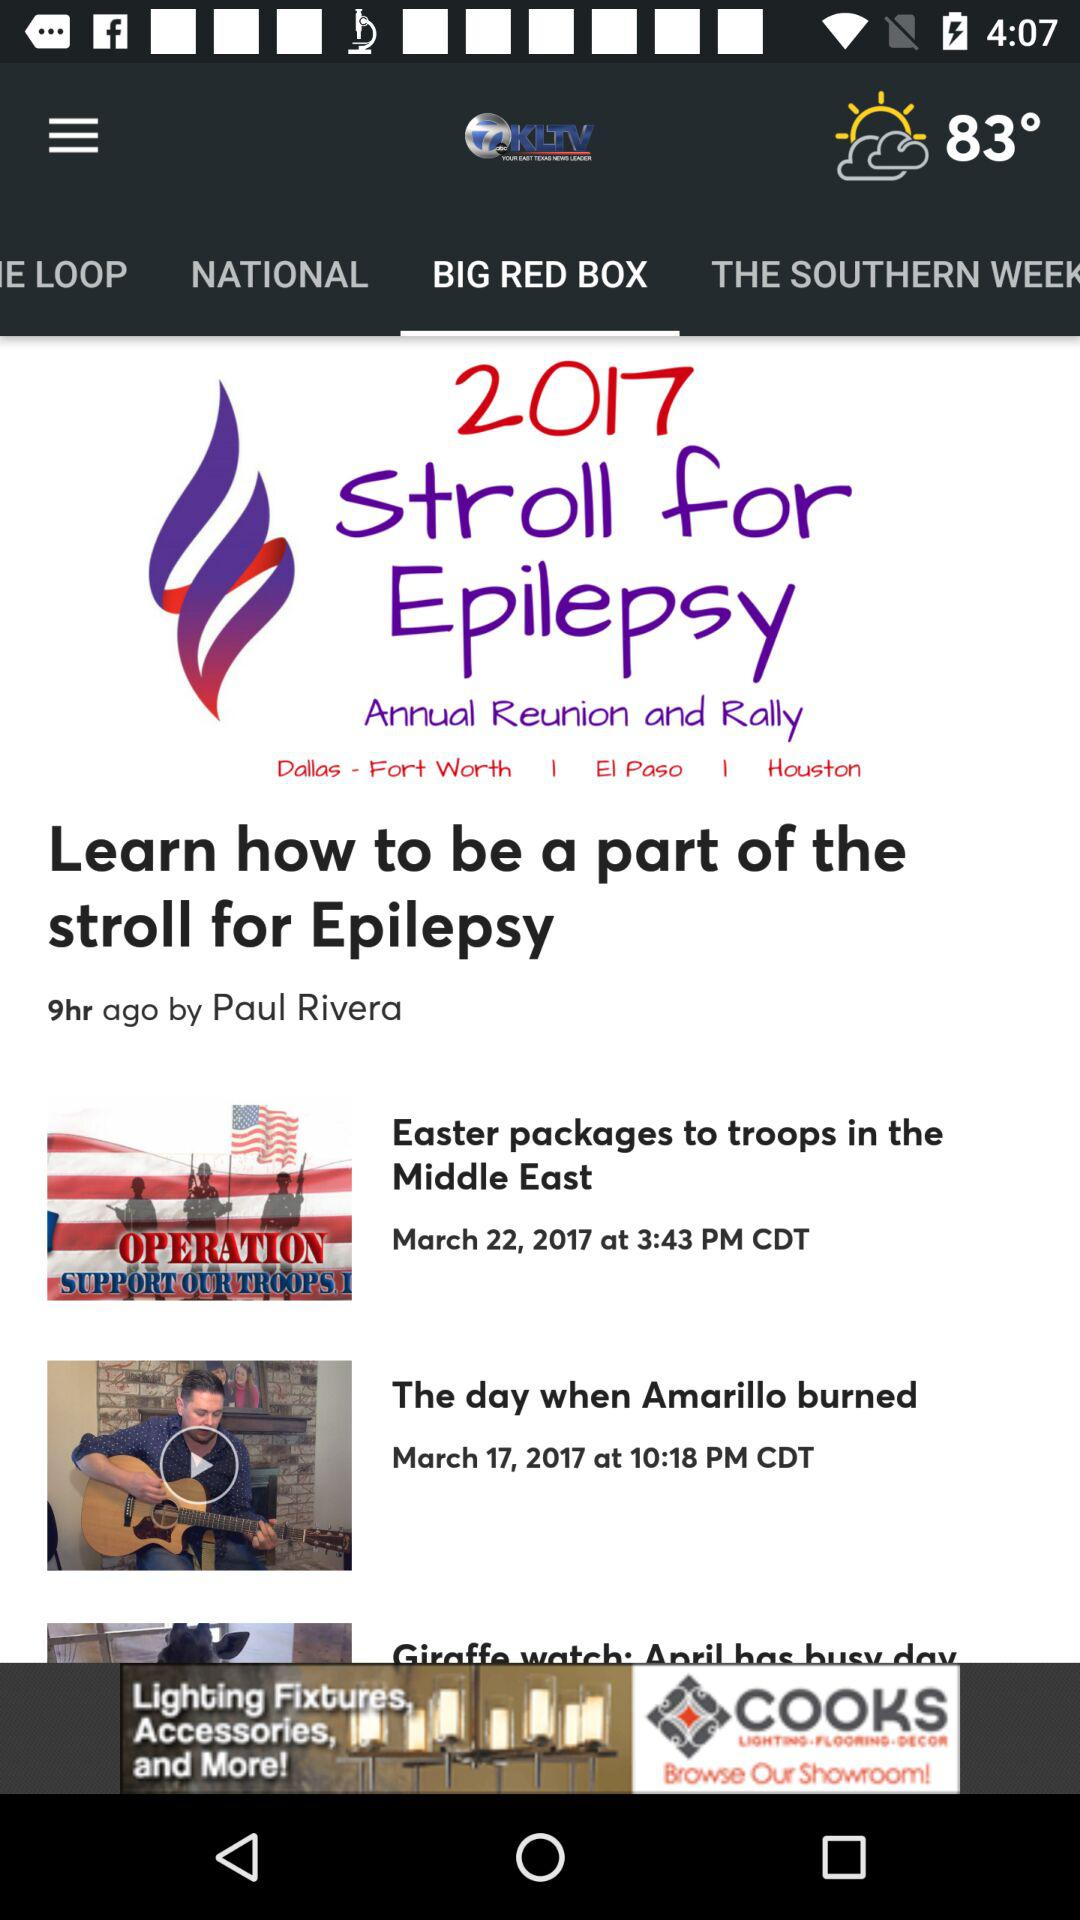What is the author name? The author name is Paul Rivera. 